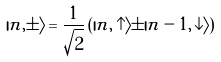<formula> <loc_0><loc_0><loc_500><loc_500>| n , \pm \rangle = \frac { 1 } { \sqrt { 2 } } \left ( | n , \uparrow \rangle \pm | n - 1 , \downarrow \rangle \right )</formula> 